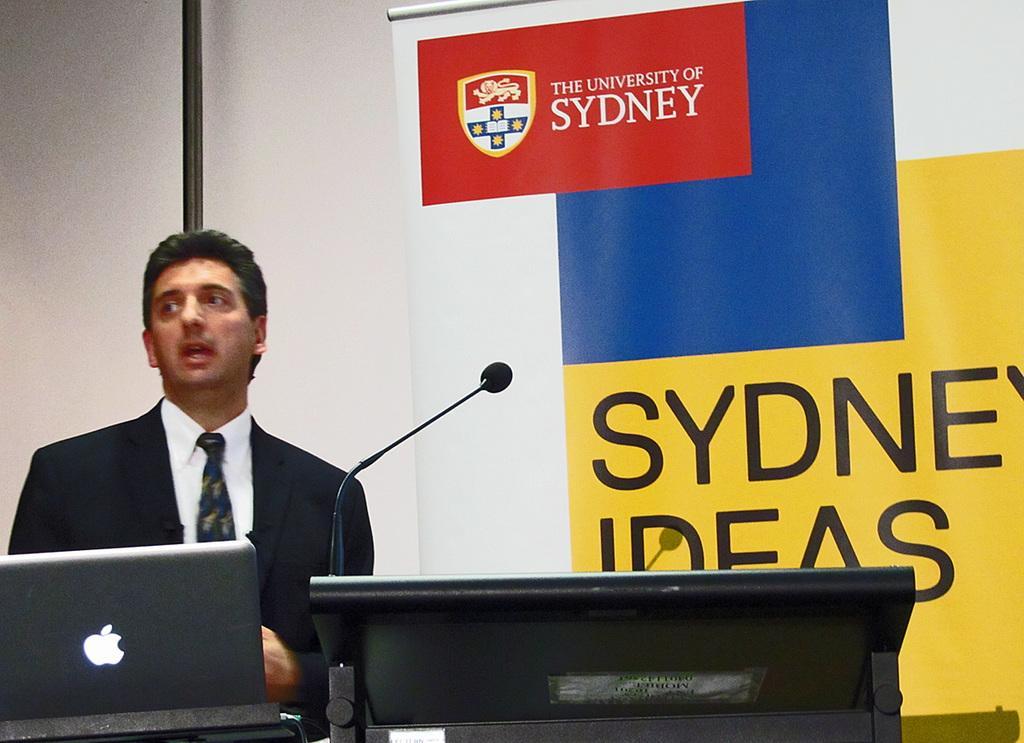How would you summarize this image in a sentence or two? In this image we can see a man. In front of him there is a laptop. Also there is a mic on a stand. In the back there is a banner with emblem and text. 